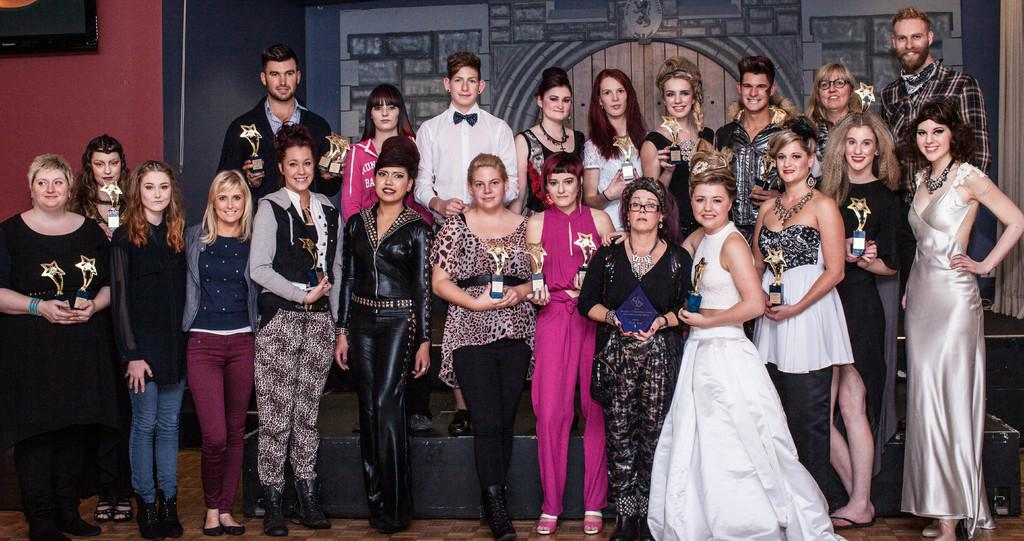How many people are in the image? There is a group of people in the image. What are the people wearing? The people are wearing clothes. Where are the people standing in the image? The people are standing in front of a wall. What are the people holding in their hands? The people are holding shields with their hands. What type of juice is being served in the image? There is no juice present in the image; the people are holding shields. 